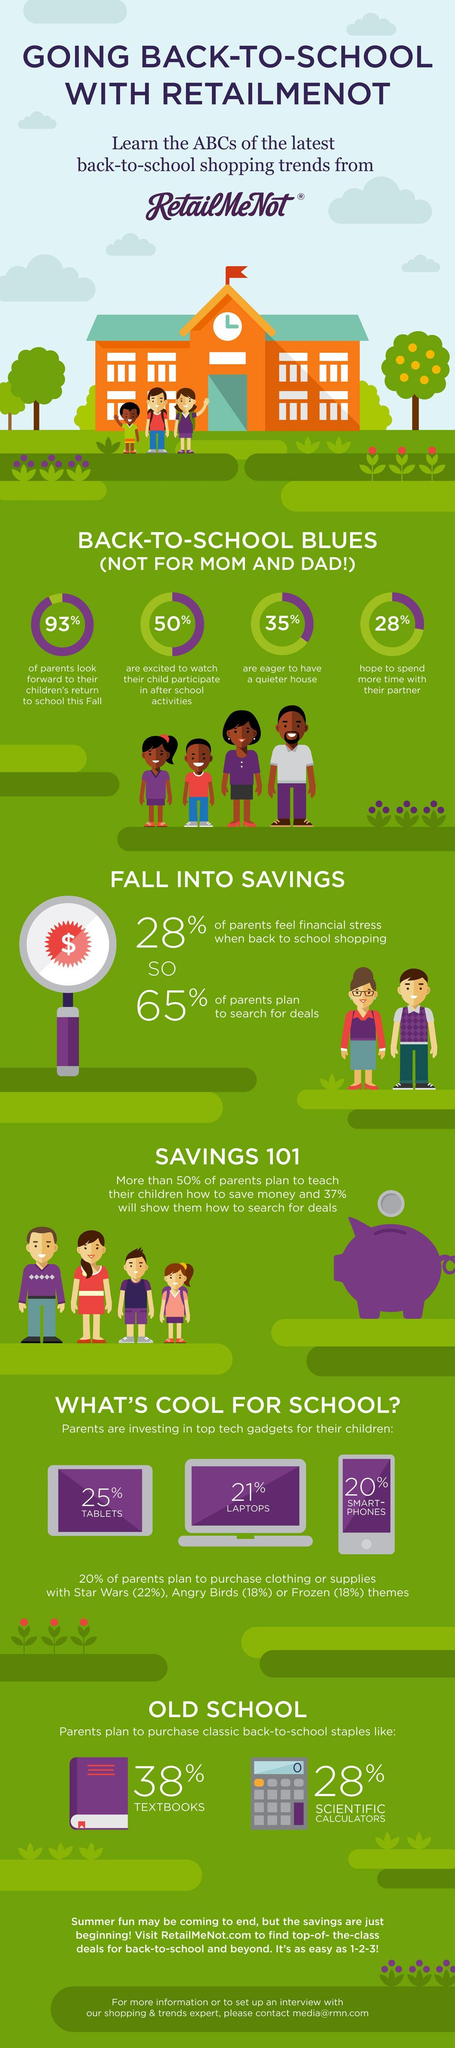What percentage of parents are excited to watch their child participate in after school activities?
Answer the question with a short phrase. 50% What percentage of parents are planning to purchase clothing or supplies with Star Wars theme? 22% What percentage of parents are planning to purchase clothing or supplies with a theme? 20% What percentage of parents are eager to have a quiter house? 35% What percentage of parents are planning to purchase clothing or supplies with Frozen theme? 18% What percentage of parents are planning to purchase clothing or supplies with Angry Birds theme? 18% 